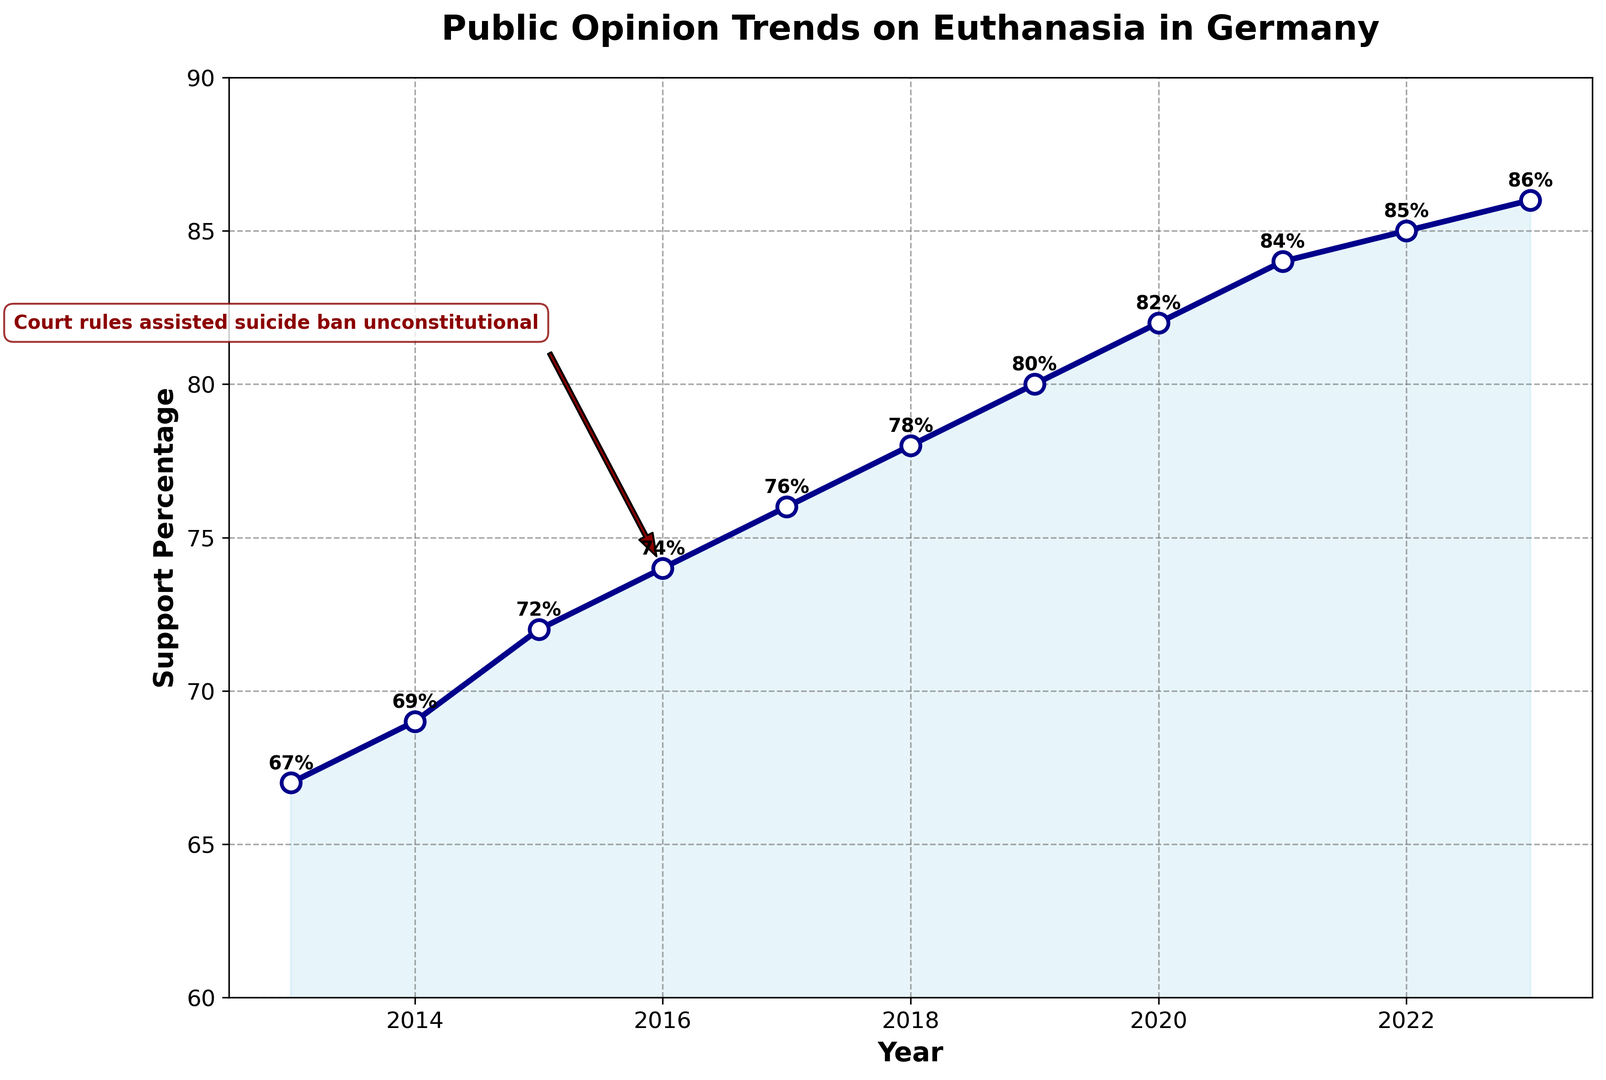What event is highlighted in the annotation on the figure? The figure shows a highlighted annotation pointing to the year 2016, indicating a key event: "Court rules assisted suicide ban unconstitutional." The annotation includes an arrow pointing directly to the data point corresponding to 2016.
Answer: Court rules assisted suicide ban unconstitutional What was the support percentage for euthanasia in Germany in 2016? To find the support percentage for euthanasia in 2016, refer to the data point directly corresponding to the year 2016 on the x-axis. The y-axis value for this point shows the support percentage.
Answer: 74% How did public support for euthanasia change from 2015 to 2017? First, check the support percentages for 2015 and 2017, which are 72% and 76%, respectively. Calculate the change by subtracting the 2015 value from the 2017 value.
Answer: Increased by 4 percentage points What is the average support percentage for euthanasia between 2013 and 2017? Identify the support percentages for the years 2013 through 2017 (67%, 69%, 72%, 74%, 76%). Add these percentages together and divide by the number of years (5). The calculation is (67 + 69 + 72 + 74 + 76) / 5 = 358 / 5.
Answer: 71.6% By how much did the support for euthanasia increase from 2013 to 2023? The support percentage for 2013 is 67%, and for 2023 is 86%. Calculate the difference by subtracting the 2013 value from the 2023 value: 86 - 67.
Answer: Increased by 19 percentage points Which year experienced the largest annual increase in support for euthanasia? To determine the largest annual increase, calculate the difference in support percentages year-over-year. Compare these differences, looking for the largest value. Differences: 2% (2013-2014), 3% (2014-2015), 2% (2015-2016), 2% (2016-2017), 2% (2017-2018), 2% (2018-2019), 2% (2019-2020), 2% (2020-2021), 1% (2021-2022), 1% (2022-2023). The largest increase is 3% from 2014 to 2015.
Answer: 2014 to 2015 What's the median support percentage from 2013 to 2023? List the support percentages in ascending order: 67%, 69%, 72%, 74%, 76%, 78%, 80%, 82%, 84%, 85%, 86%. The median is the middle value in this ordered list, which is the 6th value since there are 11 data points.
Answer: 78% How does the support percentage trend visually change after the 2016 event? From 2017 onwards, check if there's a notable visual change in the slope of the trend line. The support percentages continue to rise steadily without significant deviation in the growth rate, indicating a consistent increase.
Answer: Continues to rise steadily In which year did the support for euthanasia first exceed 80%? Check the support percentages year-by-year until the value exceeds 80%. The data shows 80% in 2019 and increases to 82% in 2020. Thus, 2020 is the first year it exceeded 80%.
Answer: 2020 